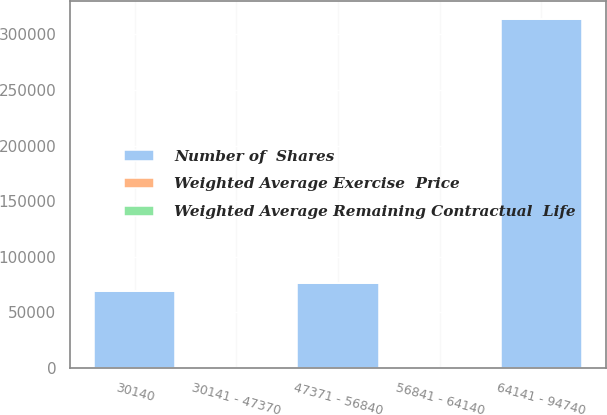Convert chart to OTSL. <chart><loc_0><loc_0><loc_500><loc_500><stacked_bar_chart><ecel><fcel>30140<fcel>30141 - 47370<fcel>47371 - 56840<fcel>56841 - 64140<fcel>64141 - 94740<nl><fcel>Number of  Shares<fcel>69000<fcel>46.63<fcel>75958<fcel>46.63<fcel>314100<nl><fcel>Weighted Average Exercise  Price<fcel>4<fcel>6.3<fcel>7.9<fcel>7<fcel>9.1<nl><fcel>Weighted Average Remaining Contractual  Life<fcel>30.14<fcel>46.63<fcel>52.04<fcel>59.11<fcel>78.58<nl></chart> 